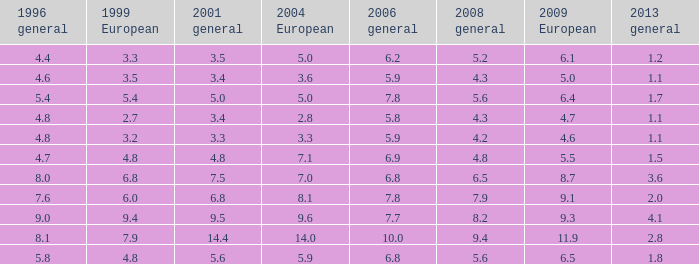How many values for 1999 European correspond to a value more than 4.7 in 2009 European, general 2001 more than 7.5, 2006 general at 10, and more than 9.4 in general 2008? 0.0. 